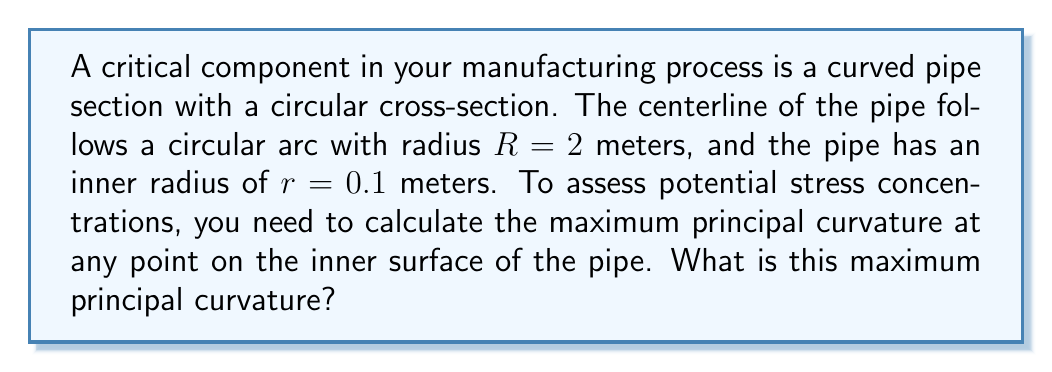Can you solve this math problem? To solve this problem, we'll follow these steps:

1) In differential geometry, the principal curvatures of a surface are the maximum and minimum curvatures of the surface at each point.

2) For a toroidal surface (which is what we have here), the principal curvatures are given by:

   $$k_1 = \frac{\cos\theta}{r}$$
   $$k_2 = \frac{1}{R + r\sin\theta}$$

   where $\theta$ is the angle around the circular cross-section.

3) The maximum principal curvature will be the larger of these two at any point.

4) $k_1$ is maximized when $\cos\theta = 1$, i.e., at $\theta = 0$ or $\theta = 2\pi$. At these points:

   $$k_1 = \frac{1}{r} = \frac{1}{0.1} = 10 \text{ m}^{-1}$$

5) $k_2$ is maximized when the denominator is at its minimum, which occurs when $\sin\theta = -1$, i.e., at $\theta = \frac{3\pi}{2}$. At this point:

   $$k_2 = \frac{1}{R - r} = \frac{1}{2 - 0.1} = \frac{1}{1.9} \approx 0.526 \text{ m}^{-1}$$

6) Comparing these values, we see that $k_1$ is always larger than $k_2$.

Therefore, the maximum principal curvature at any point on the inner surface of the pipe is $k_1 = \frac{1}{r} = 10 \text{ m}^{-1}$.
Answer: $10 \text{ m}^{-1}$ 